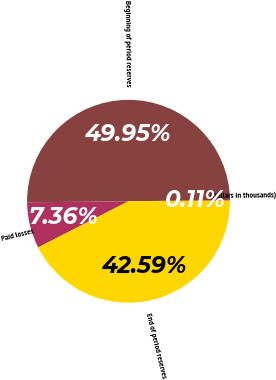<chart> <loc_0><loc_0><loc_500><loc_500><pie_chart><fcel>(Dollars in thousands)<fcel>Beginning of period reserves<fcel>Paid losses<fcel>End of period reserves<nl><fcel>0.11%<fcel>49.95%<fcel>7.36%<fcel>42.59%<nl></chart> 